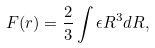Convert formula to latex. <formula><loc_0><loc_0><loc_500><loc_500>F ( r ) = \frac { 2 } { 3 } \int \epsilon R ^ { 3 } d R ,</formula> 